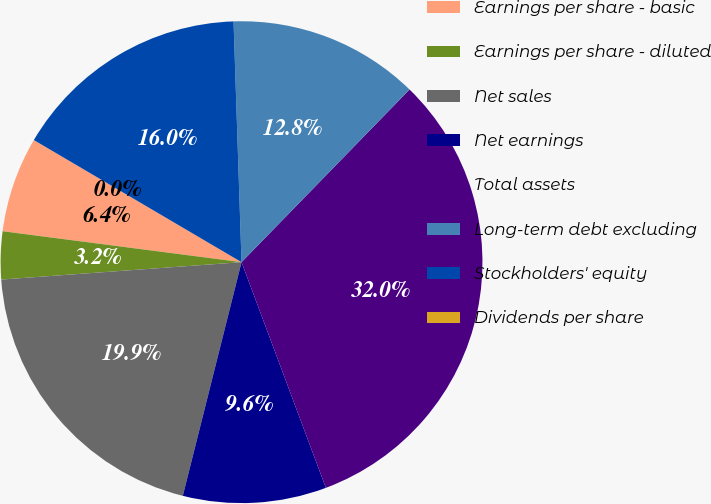Convert chart. <chart><loc_0><loc_0><loc_500><loc_500><pie_chart><fcel>Earnings per share - basic<fcel>Earnings per share - diluted<fcel>Net sales<fcel>Net earnings<fcel>Total assets<fcel>Long-term debt excluding<fcel>Stockholders' equity<fcel>Dividends per share<nl><fcel>6.41%<fcel>3.2%<fcel>19.93%<fcel>9.61%<fcel>32.02%<fcel>12.81%<fcel>16.01%<fcel>0.0%<nl></chart> 